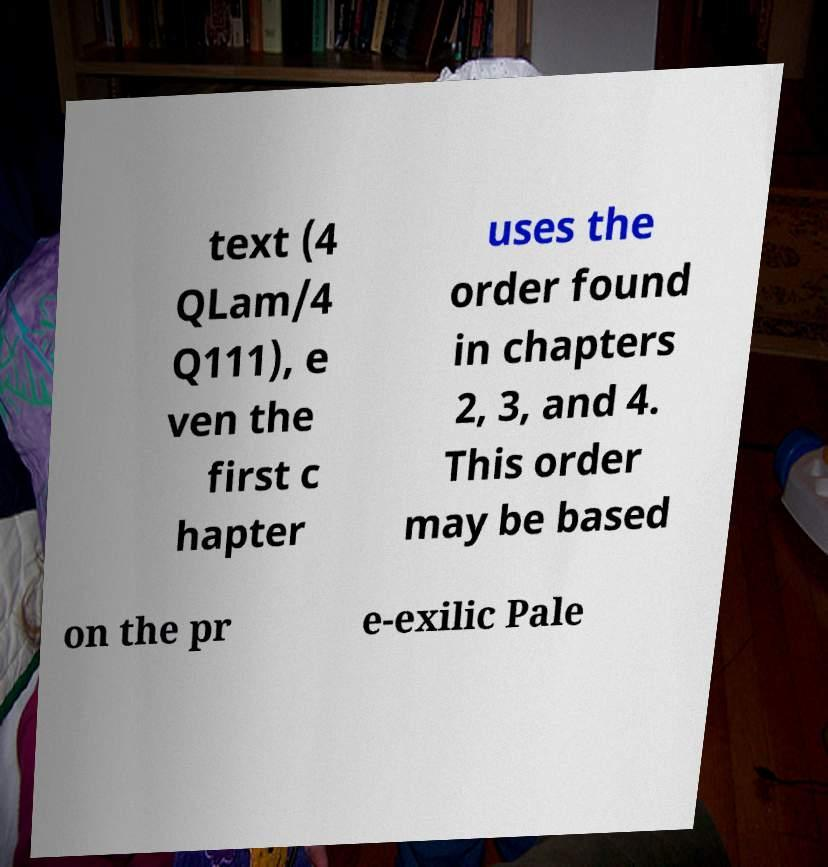There's text embedded in this image that I need extracted. Can you transcribe it verbatim? text (4 QLam/4 Q111), e ven the first c hapter uses the order found in chapters 2, 3, and 4. This order may be based on the pr e-exilic Pale 